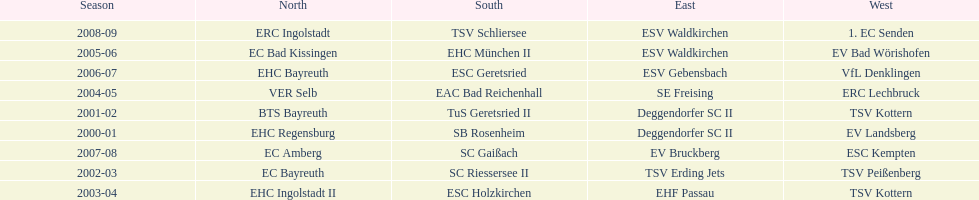Which teams won the north in their respective years? 2000-01, EHC Regensburg, BTS Bayreuth, EC Bayreuth, EHC Ingolstadt II, VER Selb, EC Bad Kissingen, EHC Bayreuth, EC Amberg, ERC Ingolstadt. Which one only won in 2000-01? EHC Regensburg. 